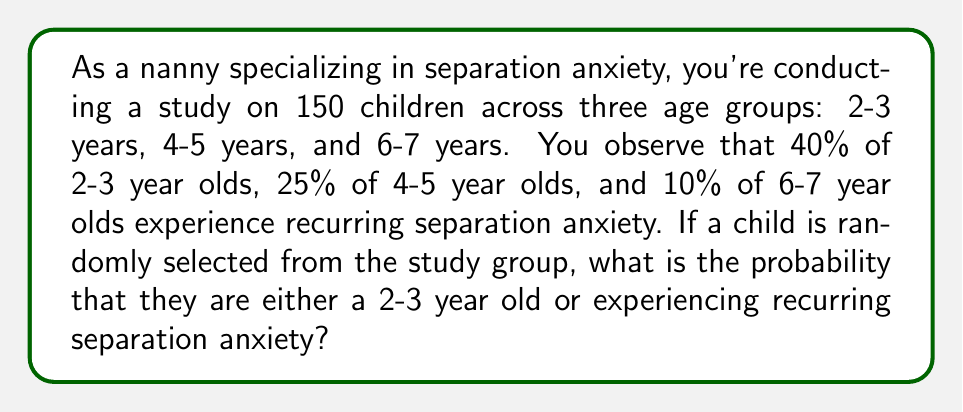Provide a solution to this math problem. Let's approach this step-by-step:

1) First, we need to calculate the probability of each event:

   Let A = event that a child is 2-3 years old
   Let B = event that a child experiences recurring separation anxiety

2) We're not given the exact number of children in each age group, so let's assume they're equally distributed:
   
   $P(A) = \frac{1}{3}$

3) To calculate P(B), we need to use the law of total probability:

   $P(B) = P(B|2-3) \cdot P(2-3) + P(B|4-5) \cdot P(4-5) + P(B|6-7) \cdot P(6-7)$
   
   $P(B) = 0.40 \cdot \frac{1}{3} + 0.25 \cdot \frac{1}{3} + 0.10 \cdot \frac{1}{3}$
   
   $P(B) = \frac{0.40 + 0.25 + 0.10}{3} = \frac{0.75}{3} = 0.25$

4) Now, we need to find $P(A \cup B)$, which is the probability of either A or B occurring:

   $P(A \cup B) = P(A) + P(B) - P(A \cap B)$

5) We need to calculate $P(A \cap B)$, which is the probability of both A and B occurring:

   $P(A \cap B) = P(B|A) \cdot P(A) = 0.40 \cdot \frac{1}{3} = \frac{0.40}{3}$

6) Now we can calculate $P(A \cup B)$:

   $P(A \cup B) = \frac{1}{3} + 0.25 - \frac{0.40}{3}$
   
   $P(A \cup B) = \frac{1}{3} + \frac{0.75}{3} - \frac{0.40}{3} = \frac{1.35}{3} = 0.45$

Therefore, the probability is 0.45 or 45%.
Answer: 0.45 